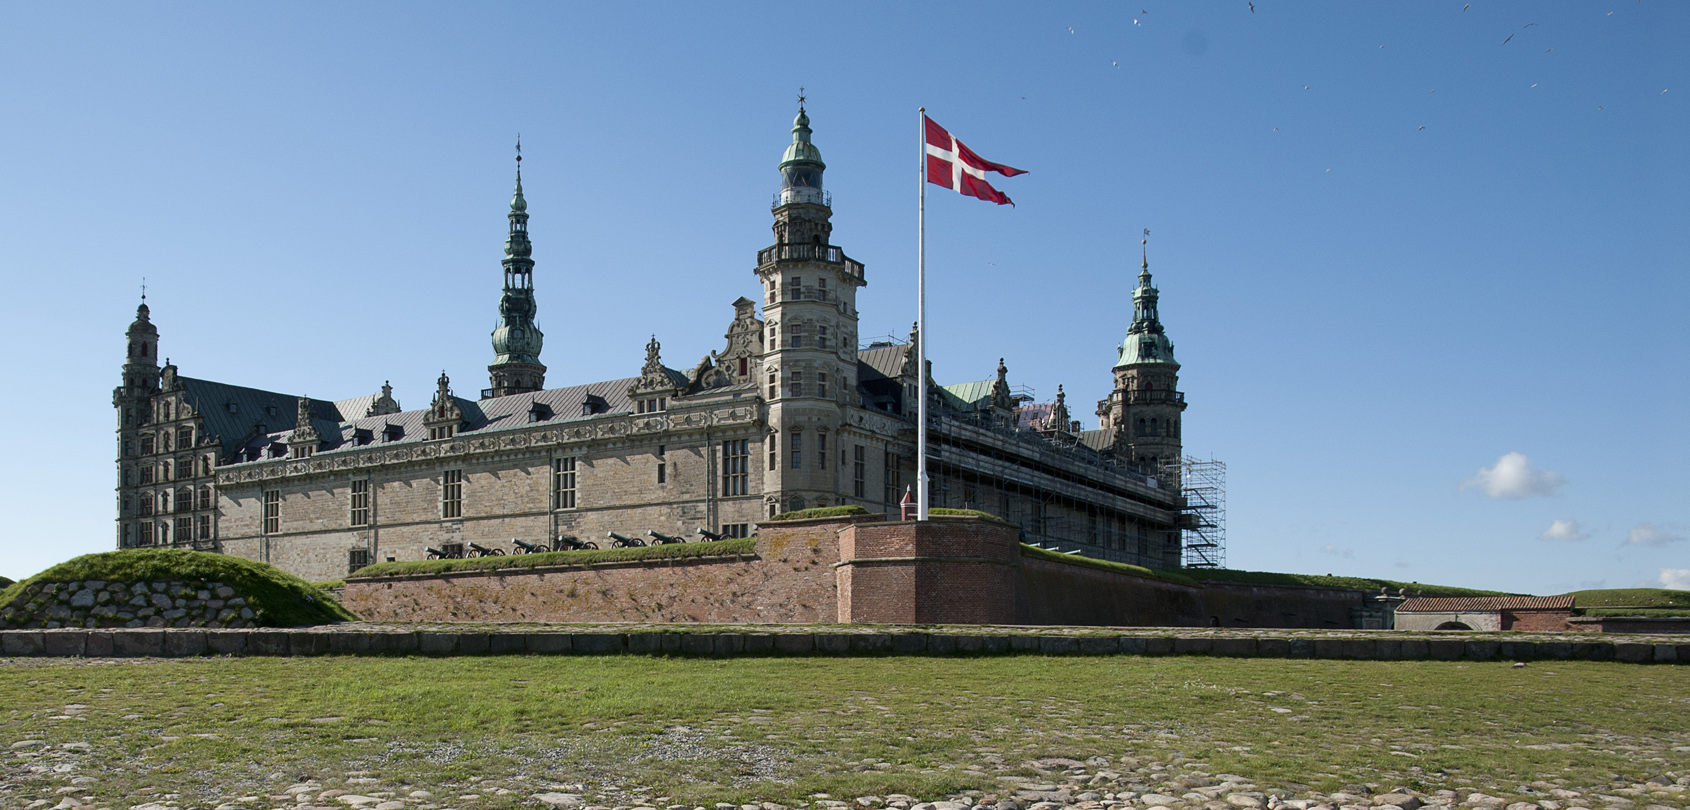Imagine an alternate history where this castle was never built. How might the region around it have developed differently? In an alternate history where Kronborg Castle was never constructed, the region around Helsingør might have evolved in a distinctly different manner. The strategic control over the Oresund Strait might have fallen to another power, altering local trade, economics, and even language influences. Without the castle as a defensive stronghold, the area may have been more vulnerable to conflicts, perhaps leading to a less stable historical trajectory. Culturally, the inspiration behind Shakespeare’s 'Hamlet' could have shifted, with another location in the region potentially gaining prominence in literature and tourism. The absence of this architectural gem might have meant fewer preservation efforts, leading to a different urban layout and possibly a less robust heritage tourism industry in Helsingør. 